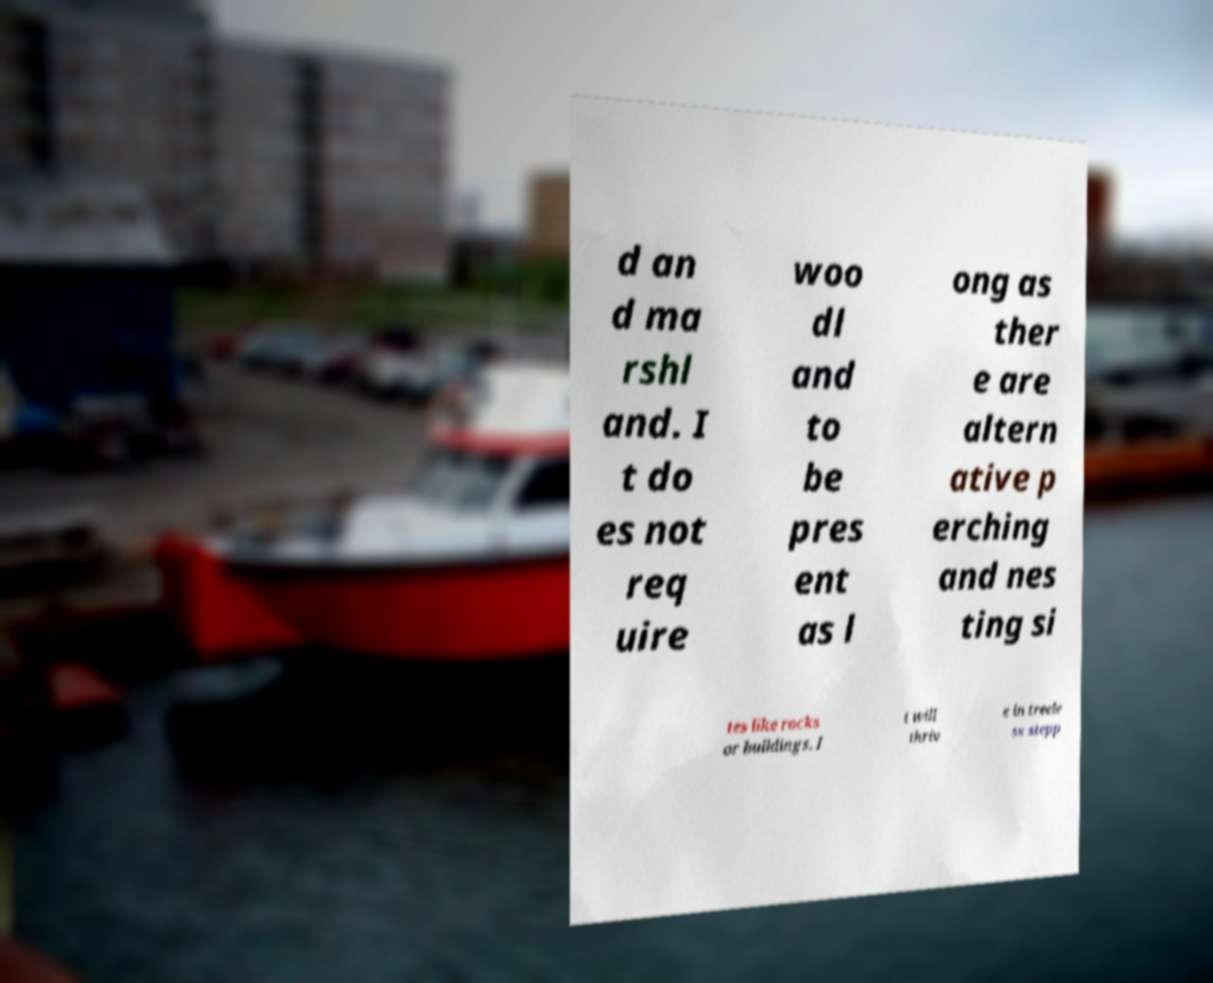Can you accurately transcribe the text from the provided image for me? d an d ma rshl and. I t do es not req uire woo dl and to be pres ent as l ong as ther e are altern ative p erching and nes ting si tes like rocks or buildings. I t will thriv e in treele ss stepp 